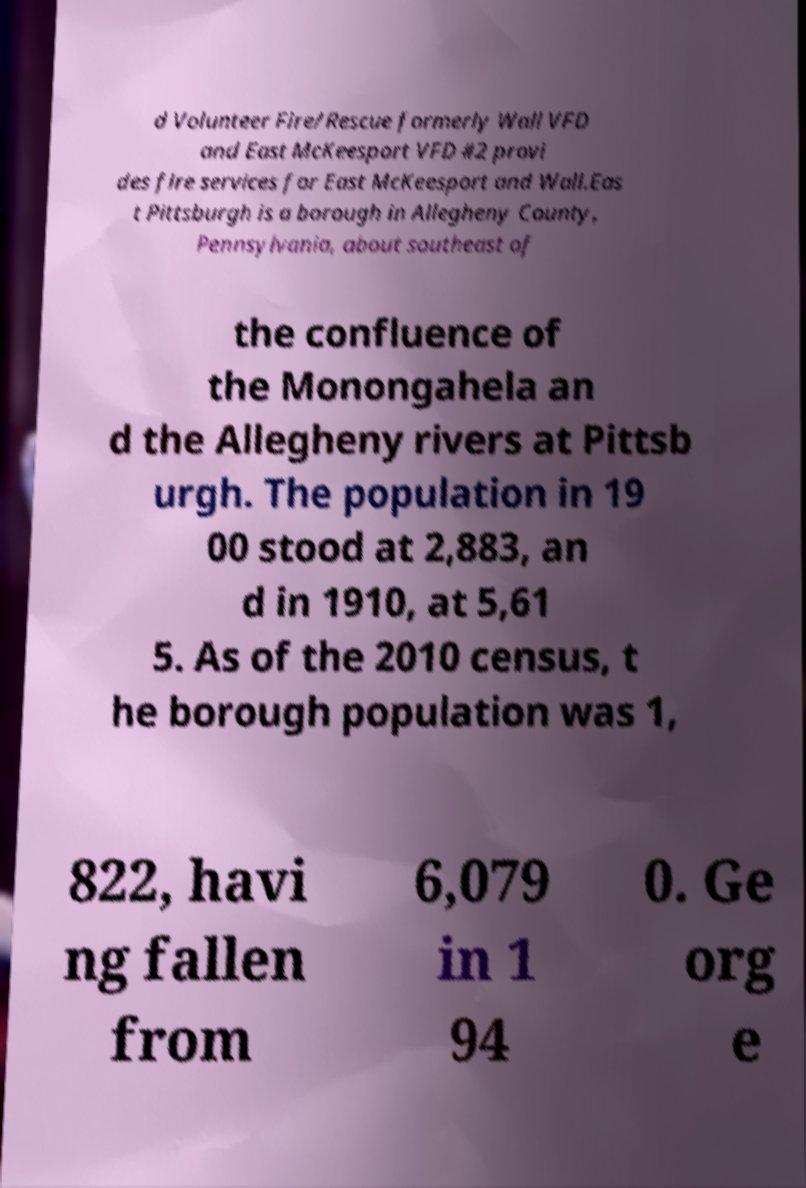For documentation purposes, I need the text within this image transcribed. Could you provide that? d Volunteer Fire/Rescue formerly Wall VFD and East McKeesport VFD #2 provi des fire services for East McKeesport and Wall.Eas t Pittsburgh is a borough in Allegheny County, Pennsylvania, about southeast of the confluence of the Monongahela an d the Allegheny rivers at Pittsb urgh. The population in 19 00 stood at 2,883, an d in 1910, at 5,61 5. As of the 2010 census, t he borough population was 1, 822, havi ng fallen from 6,079 in 1 94 0. Ge org e 